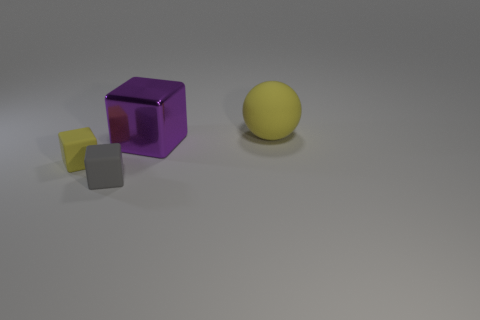Are there any other things that have the same material as the large block?
Provide a short and direct response. No. Does the purple thing have the same shape as the yellow object that is to the left of the big yellow thing?
Your response must be concise. Yes. What number of things are either large blue matte things or gray rubber cubes?
Offer a very short reply. 1. What is the shape of the purple metal object left of the yellow matte object that is to the right of the tiny gray cube?
Make the answer very short. Cube. Does the yellow matte thing that is in front of the large ball have the same shape as the big shiny object?
Keep it short and to the point. Yes. There is another cube that is made of the same material as the yellow block; what is its size?
Make the answer very short. Small. How many objects are either blocks behind the tiny gray matte block or matte objects behind the small gray block?
Give a very brief answer. 3. Are there an equal number of gray matte objects on the right side of the large yellow thing and tiny objects behind the purple object?
Give a very brief answer. Yes. There is a cube that is behind the tiny yellow object; what color is it?
Offer a very short reply. Purple. There is a rubber ball; is it the same color as the small object that is behind the small gray matte cube?
Your answer should be compact. Yes. 